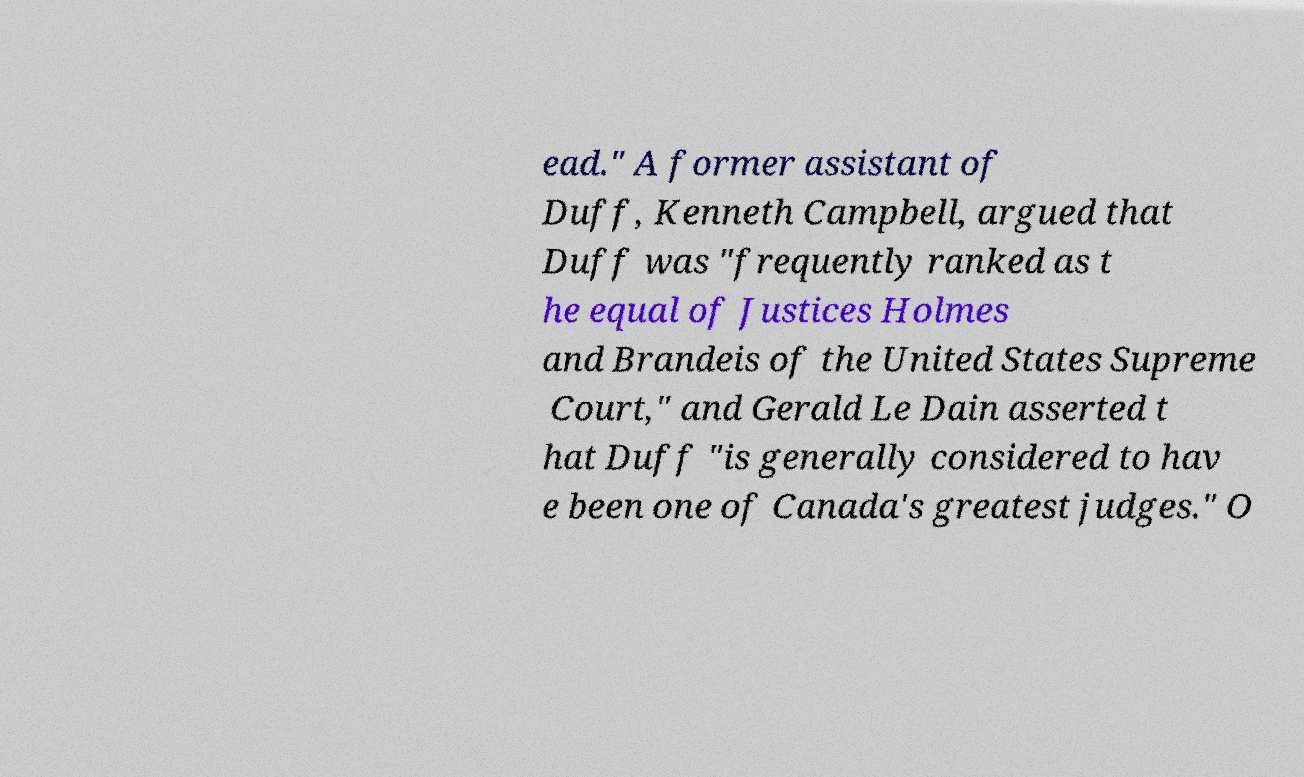Please identify and transcribe the text found in this image. ead." A former assistant of Duff, Kenneth Campbell, argued that Duff was "frequently ranked as t he equal of Justices Holmes and Brandeis of the United States Supreme Court," and Gerald Le Dain asserted t hat Duff "is generally considered to hav e been one of Canada's greatest judges." O 